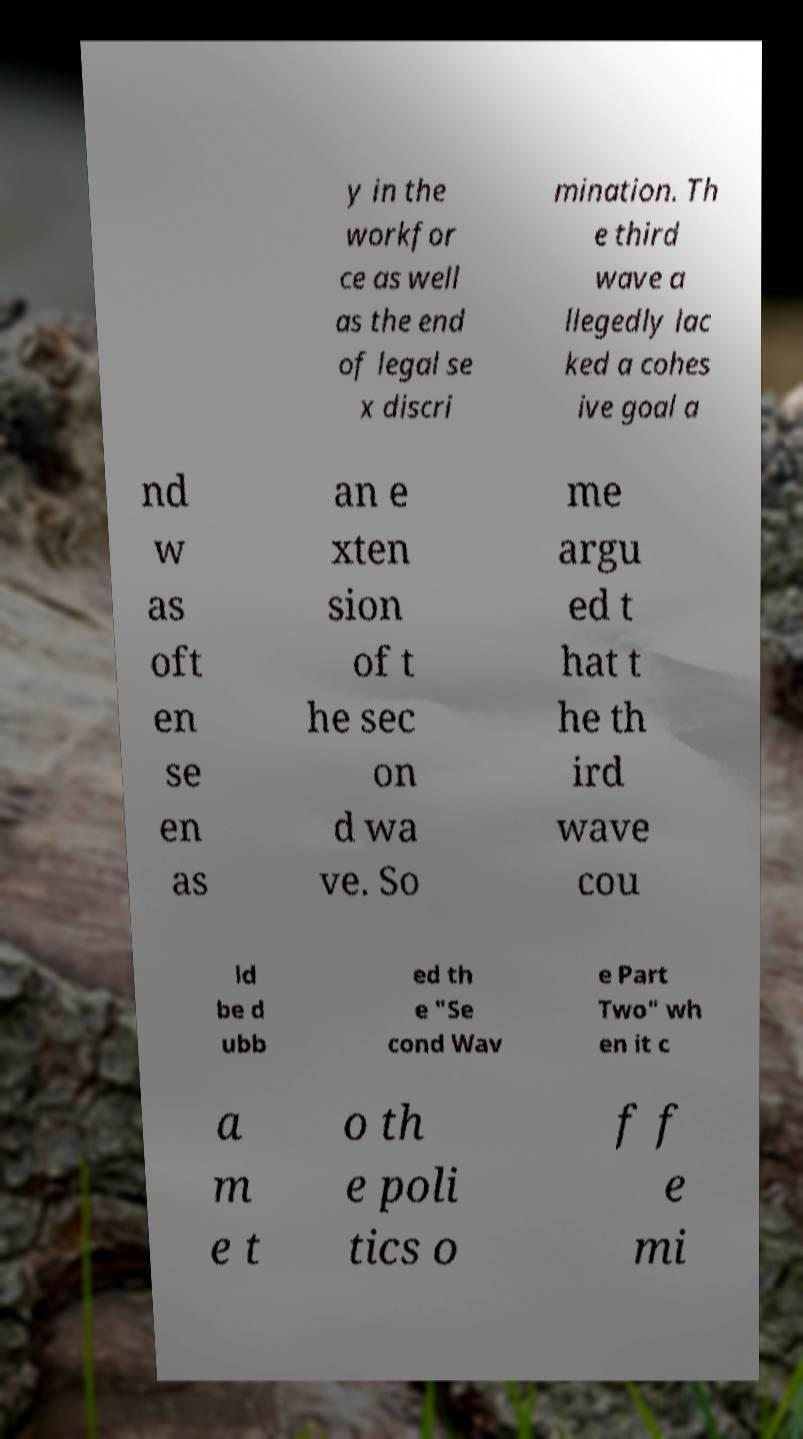What messages or text are displayed in this image? I need them in a readable, typed format. y in the workfor ce as well as the end of legal se x discri mination. Th e third wave a llegedly lac ked a cohes ive goal a nd w as oft en se en as an e xten sion of t he sec on d wa ve. So me argu ed t hat t he th ird wave cou ld be d ubb ed th e "Se cond Wav e Part Two" wh en it c a m e t o th e poli tics o f f e mi 